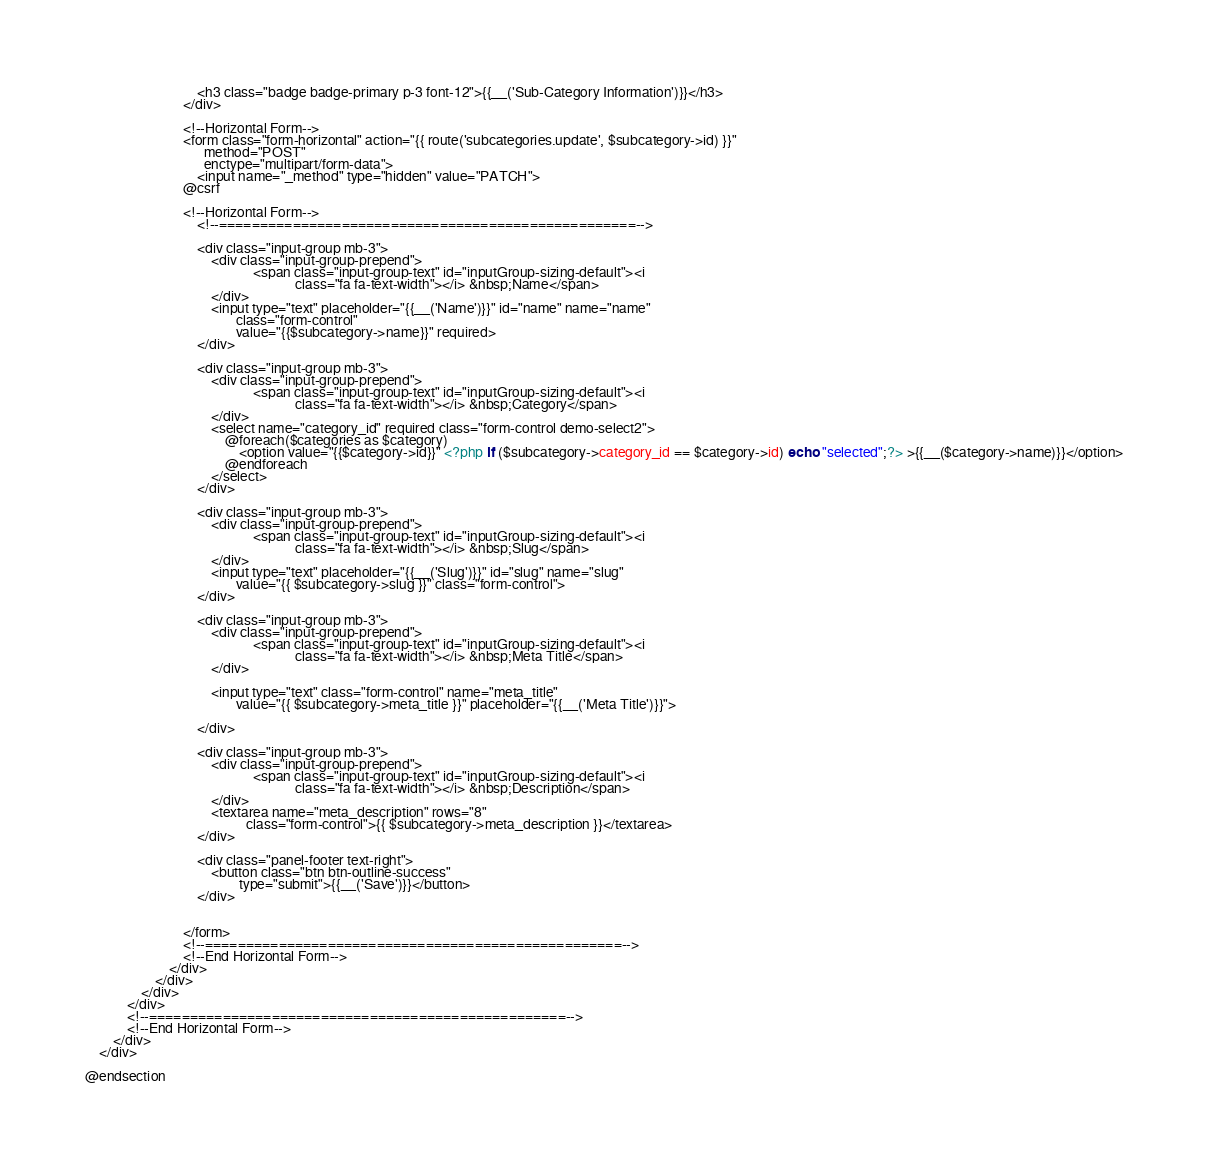<code> <loc_0><loc_0><loc_500><loc_500><_PHP_>                                <h3 class="badge badge-primary p-3 font-12">{{__('Sub-Category Information')}}</h3>
                            </div>

                            <!--Horizontal Form-->
                            <form class="form-horizontal" action="{{ route('subcategories.update', $subcategory->id) }}"
                                  method="POST"
                                  enctype="multipart/form-data">
                                <input name="_method" type="hidden" value="PATCH">
                            @csrf

                            <!--Horizontal Form-->
                                <!--===================================================-->

                                <div class="input-group mb-3">
                                    <div class="input-group-prepend">
                                                <span class="input-group-text" id="inputGroup-sizing-default"><i
                                                            class="fa fa-text-width"></i> &nbsp;Name</span>
                                    </div>
                                    <input type="text" placeholder="{{__('Name')}}" id="name" name="name"
                                           class="form-control"
                                           value="{{$subcategory->name}}" required>
                                </div>

                                <div class="input-group mb-3">
                                    <div class="input-group-prepend">
                                                <span class="input-group-text" id="inputGroup-sizing-default"><i
                                                            class="fa fa-text-width"></i> &nbsp;Category</span>
                                    </div>
                                    <select name="category_id" required class="form-control demo-select2">
                                        @foreach($categories as $category)
                                            <option value="{{$category->id}}" <?php if ($subcategory->category_id == $category->id) echo "selected";?> >{{__($category->name)}}</option>
                                        @endforeach
                                    </select>
                                </div>

                                <div class="input-group mb-3">
                                    <div class="input-group-prepend">
                                                <span class="input-group-text" id="inputGroup-sizing-default"><i
                                                            class="fa fa-text-width"></i> &nbsp;Slug</span>
                                    </div>
                                    <input type="text" placeholder="{{__('Slug')}}" id="slug" name="slug"
                                           value="{{ $subcategory->slug }}" class="form-control">
                                </div>

                                <div class="input-group mb-3">
                                    <div class="input-group-prepend">
                                                <span class="input-group-text" id="inputGroup-sizing-default"><i
                                                            class="fa fa-text-width"></i> &nbsp;Meta Title</span>
                                    </div>

                                    <input type="text" class="form-control" name="meta_title"
                                           value="{{ $subcategory->meta_title }}" placeholder="{{__('Meta Title')}}">

                                </div>

                                <div class="input-group mb-3">
                                    <div class="input-group-prepend">
                                                <span class="input-group-text" id="inputGroup-sizing-default"><i
                                                            class="fa fa-text-width"></i> &nbsp;Description</span>
                                    </div>
                                    <textarea name="meta_description" rows="8"
                                              class="form-control">{{ $subcategory->meta_description }}</textarea>
                                </div>

                                <div class="panel-footer text-right">
                                    <button class="btn btn-outline-success"
                                            type="submit">{{__('Save')}}</button>
                                </div>


                            </form>
                            <!--===================================================-->
                            <!--End Horizontal Form-->
                        </div>
                    </div>
                </div>
            </div>
            <!--===================================================-->
            <!--End Horizontal Form-->
        </div>
    </div>

@endsection
</code> 